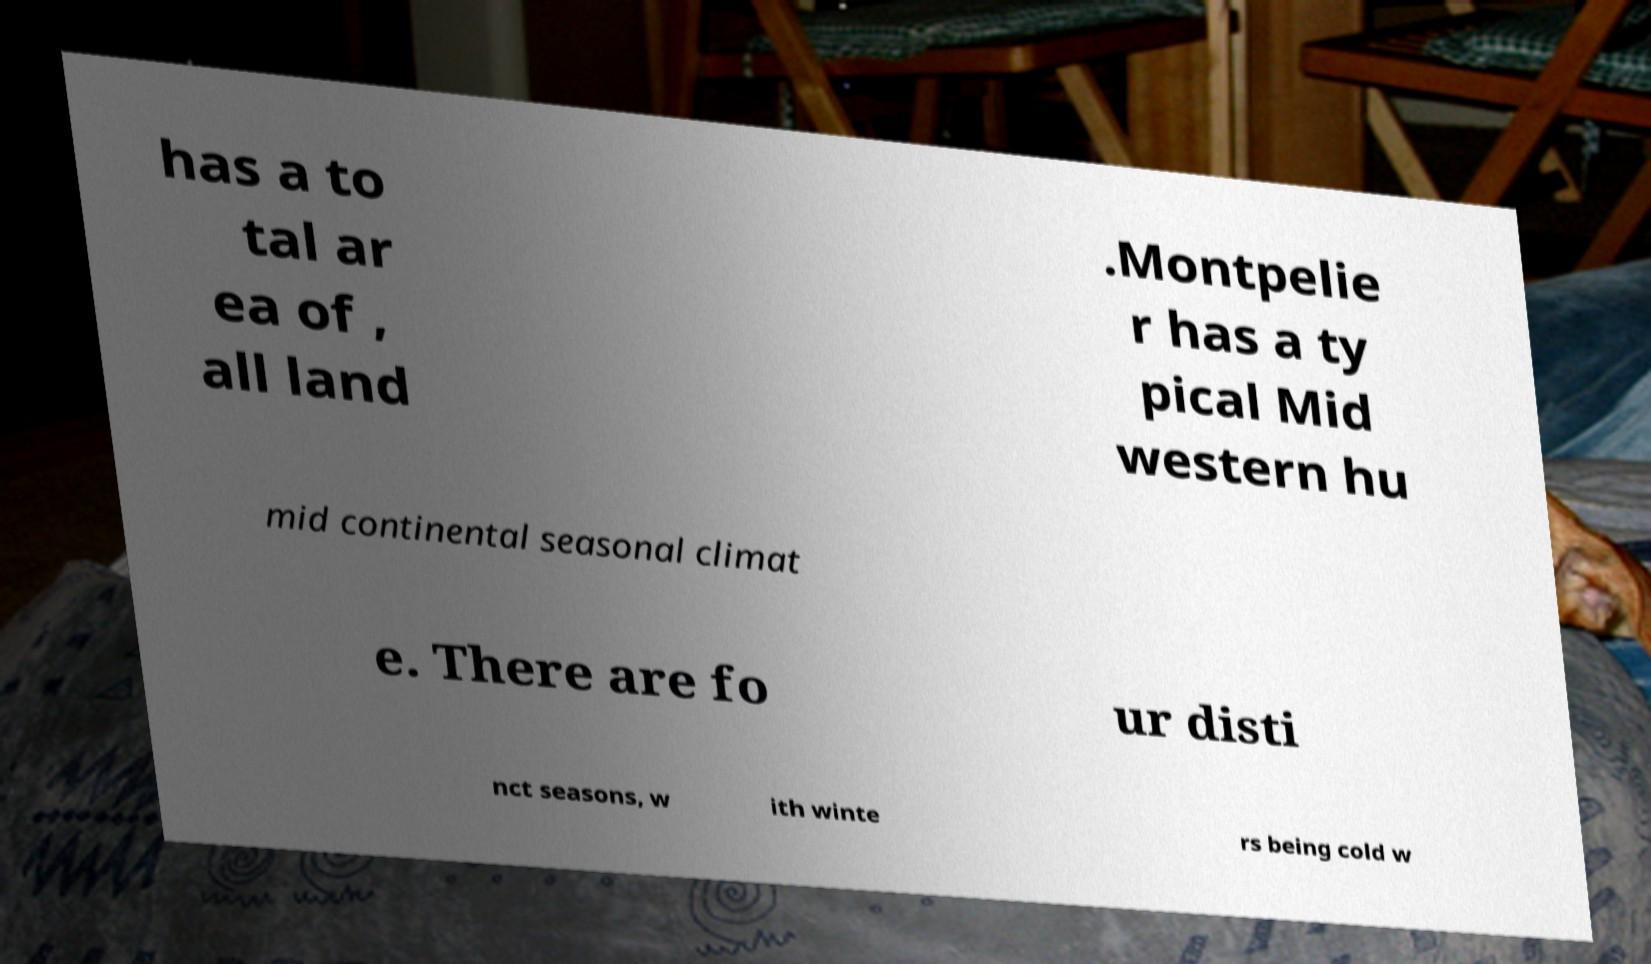Please read and relay the text visible in this image. What does it say? has a to tal ar ea of , all land .Montpelie r has a ty pical Mid western hu mid continental seasonal climat e. There are fo ur disti nct seasons, w ith winte rs being cold w 